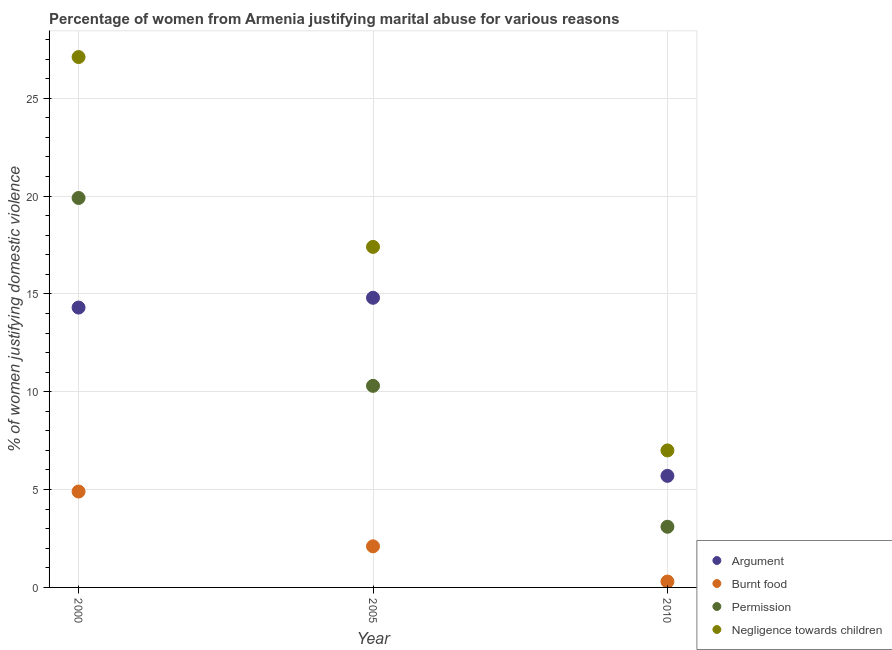Is the number of dotlines equal to the number of legend labels?
Give a very brief answer. Yes. What is the percentage of women justifying abuse for showing negligence towards children in 2005?
Make the answer very short. 17.4. Across all years, what is the maximum percentage of women justifying abuse for going without permission?
Ensure brevity in your answer.  19.9. Across all years, what is the minimum percentage of women justifying abuse for burning food?
Your response must be concise. 0.3. What is the total percentage of women justifying abuse for going without permission in the graph?
Ensure brevity in your answer.  33.3. What is the difference between the percentage of women justifying abuse for showing negligence towards children in 2000 and that in 2005?
Make the answer very short. 9.7. What is the difference between the percentage of women justifying abuse for showing negligence towards children in 2000 and the percentage of women justifying abuse for going without permission in 2005?
Provide a short and direct response. 16.8. What is the average percentage of women justifying abuse for going without permission per year?
Offer a terse response. 11.1. In the year 2005, what is the difference between the percentage of women justifying abuse in the case of an argument and percentage of women justifying abuse for showing negligence towards children?
Make the answer very short. -2.6. In how many years, is the percentage of women justifying abuse in the case of an argument greater than 8 %?
Provide a short and direct response. 2. What is the ratio of the percentage of women justifying abuse for showing negligence towards children in 2000 to that in 2010?
Provide a succinct answer. 3.87. What is the difference between the highest and the second highest percentage of women justifying abuse for showing negligence towards children?
Your answer should be very brief. 9.7. What is the difference between the highest and the lowest percentage of women justifying abuse for showing negligence towards children?
Give a very brief answer. 20.1. Is the sum of the percentage of women justifying abuse for showing negligence towards children in 2005 and 2010 greater than the maximum percentage of women justifying abuse for going without permission across all years?
Ensure brevity in your answer.  Yes. Does the percentage of women justifying abuse for burning food monotonically increase over the years?
Provide a short and direct response. No. Is the percentage of women justifying abuse in the case of an argument strictly less than the percentage of women justifying abuse for burning food over the years?
Offer a terse response. No. Are the values on the major ticks of Y-axis written in scientific E-notation?
Your answer should be compact. No. Does the graph contain grids?
Offer a terse response. Yes. What is the title of the graph?
Make the answer very short. Percentage of women from Armenia justifying marital abuse for various reasons. Does "Salary of employees" appear as one of the legend labels in the graph?
Offer a terse response. No. What is the label or title of the X-axis?
Make the answer very short. Year. What is the label or title of the Y-axis?
Your answer should be very brief. % of women justifying domestic violence. What is the % of women justifying domestic violence in Argument in 2000?
Your answer should be compact. 14.3. What is the % of women justifying domestic violence in Burnt food in 2000?
Your answer should be very brief. 4.9. What is the % of women justifying domestic violence of Permission in 2000?
Offer a terse response. 19.9. What is the % of women justifying domestic violence in Negligence towards children in 2000?
Offer a very short reply. 27.1. What is the % of women justifying domestic violence of Argument in 2005?
Your answer should be very brief. 14.8. What is the % of women justifying domestic violence in Permission in 2005?
Keep it short and to the point. 10.3. What is the % of women justifying domestic violence of Burnt food in 2010?
Keep it short and to the point. 0.3. What is the % of women justifying domestic violence of Negligence towards children in 2010?
Offer a very short reply. 7. Across all years, what is the maximum % of women justifying domestic violence of Argument?
Offer a terse response. 14.8. Across all years, what is the maximum % of women justifying domestic violence in Negligence towards children?
Your response must be concise. 27.1. Across all years, what is the minimum % of women justifying domestic violence of Argument?
Your answer should be compact. 5.7. Across all years, what is the minimum % of women justifying domestic violence in Burnt food?
Your response must be concise. 0.3. Across all years, what is the minimum % of women justifying domestic violence in Permission?
Keep it short and to the point. 3.1. What is the total % of women justifying domestic violence in Argument in the graph?
Provide a succinct answer. 34.8. What is the total % of women justifying domestic violence in Permission in the graph?
Make the answer very short. 33.3. What is the total % of women justifying domestic violence of Negligence towards children in the graph?
Offer a terse response. 51.5. What is the difference between the % of women justifying domestic violence in Argument in 2000 and that in 2005?
Keep it short and to the point. -0.5. What is the difference between the % of women justifying domestic violence of Negligence towards children in 2000 and that in 2005?
Offer a terse response. 9.7. What is the difference between the % of women justifying domestic violence of Burnt food in 2000 and that in 2010?
Keep it short and to the point. 4.6. What is the difference between the % of women justifying domestic violence of Negligence towards children in 2000 and that in 2010?
Provide a short and direct response. 20.1. What is the difference between the % of women justifying domestic violence of Argument in 2005 and that in 2010?
Your response must be concise. 9.1. What is the difference between the % of women justifying domestic violence in Burnt food in 2005 and that in 2010?
Give a very brief answer. 1.8. What is the difference between the % of women justifying domestic violence of Permission in 2005 and that in 2010?
Keep it short and to the point. 7.2. What is the difference between the % of women justifying domestic violence of Negligence towards children in 2005 and that in 2010?
Keep it short and to the point. 10.4. What is the difference between the % of women justifying domestic violence of Argument in 2000 and the % of women justifying domestic violence of Burnt food in 2005?
Your response must be concise. 12.2. What is the difference between the % of women justifying domestic violence in Burnt food in 2000 and the % of women justifying domestic violence in Negligence towards children in 2005?
Keep it short and to the point. -12.5. What is the difference between the % of women justifying domestic violence in Permission in 2000 and the % of women justifying domestic violence in Negligence towards children in 2005?
Make the answer very short. 2.5. What is the difference between the % of women justifying domestic violence in Argument in 2000 and the % of women justifying domestic violence in Negligence towards children in 2010?
Ensure brevity in your answer.  7.3. What is the difference between the % of women justifying domestic violence of Permission in 2000 and the % of women justifying domestic violence of Negligence towards children in 2010?
Keep it short and to the point. 12.9. What is the difference between the % of women justifying domestic violence of Argument in 2005 and the % of women justifying domestic violence of Permission in 2010?
Offer a terse response. 11.7. What is the difference between the % of women justifying domestic violence of Burnt food in 2005 and the % of women justifying domestic violence of Permission in 2010?
Give a very brief answer. -1. What is the difference between the % of women justifying domestic violence in Burnt food in 2005 and the % of women justifying domestic violence in Negligence towards children in 2010?
Your answer should be compact. -4.9. What is the average % of women justifying domestic violence in Burnt food per year?
Offer a terse response. 2.43. What is the average % of women justifying domestic violence of Permission per year?
Keep it short and to the point. 11.1. What is the average % of women justifying domestic violence in Negligence towards children per year?
Your response must be concise. 17.17. In the year 2000, what is the difference between the % of women justifying domestic violence of Burnt food and % of women justifying domestic violence of Negligence towards children?
Offer a very short reply. -22.2. In the year 2005, what is the difference between the % of women justifying domestic violence of Burnt food and % of women justifying domestic violence of Negligence towards children?
Offer a terse response. -15.3. In the year 2010, what is the difference between the % of women justifying domestic violence in Argument and % of women justifying domestic violence in Negligence towards children?
Your answer should be compact. -1.3. In the year 2010, what is the difference between the % of women justifying domestic violence of Burnt food and % of women justifying domestic violence of Permission?
Your answer should be very brief. -2.8. In the year 2010, what is the difference between the % of women justifying domestic violence in Permission and % of women justifying domestic violence in Negligence towards children?
Give a very brief answer. -3.9. What is the ratio of the % of women justifying domestic violence in Argument in 2000 to that in 2005?
Offer a terse response. 0.97. What is the ratio of the % of women justifying domestic violence in Burnt food in 2000 to that in 2005?
Offer a terse response. 2.33. What is the ratio of the % of women justifying domestic violence of Permission in 2000 to that in 2005?
Provide a succinct answer. 1.93. What is the ratio of the % of women justifying domestic violence in Negligence towards children in 2000 to that in 2005?
Your answer should be compact. 1.56. What is the ratio of the % of women justifying domestic violence in Argument in 2000 to that in 2010?
Ensure brevity in your answer.  2.51. What is the ratio of the % of women justifying domestic violence in Burnt food in 2000 to that in 2010?
Ensure brevity in your answer.  16.33. What is the ratio of the % of women justifying domestic violence in Permission in 2000 to that in 2010?
Keep it short and to the point. 6.42. What is the ratio of the % of women justifying domestic violence of Negligence towards children in 2000 to that in 2010?
Your answer should be very brief. 3.87. What is the ratio of the % of women justifying domestic violence of Argument in 2005 to that in 2010?
Your answer should be very brief. 2.6. What is the ratio of the % of women justifying domestic violence in Permission in 2005 to that in 2010?
Provide a succinct answer. 3.32. What is the ratio of the % of women justifying domestic violence of Negligence towards children in 2005 to that in 2010?
Offer a very short reply. 2.49. What is the difference between the highest and the second highest % of women justifying domestic violence of Argument?
Offer a terse response. 0.5. What is the difference between the highest and the second highest % of women justifying domestic violence of Burnt food?
Your answer should be very brief. 2.8. What is the difference between the highest and the second highest % of women justifying domestic violence in Permission?
Your response must be concise. 9.6. What is the difference between the highest and the second highest % of women justifying domestic violence of Negligence towards children?
Give a very brief answer. 9.7. What is the difference between the highest and the lowest % of women justifying domestic violence of Argument?
Keep it short and to the point. 9.1. What is the difference between the highest and the lowest % of women justifying domestic violence of Permission?
Your response must be concise. 16.8. What is the difference between the highest and the lowest % of women justifying domestic violence of Negligence towards children?
Your answer should be very brief. 20.1. 